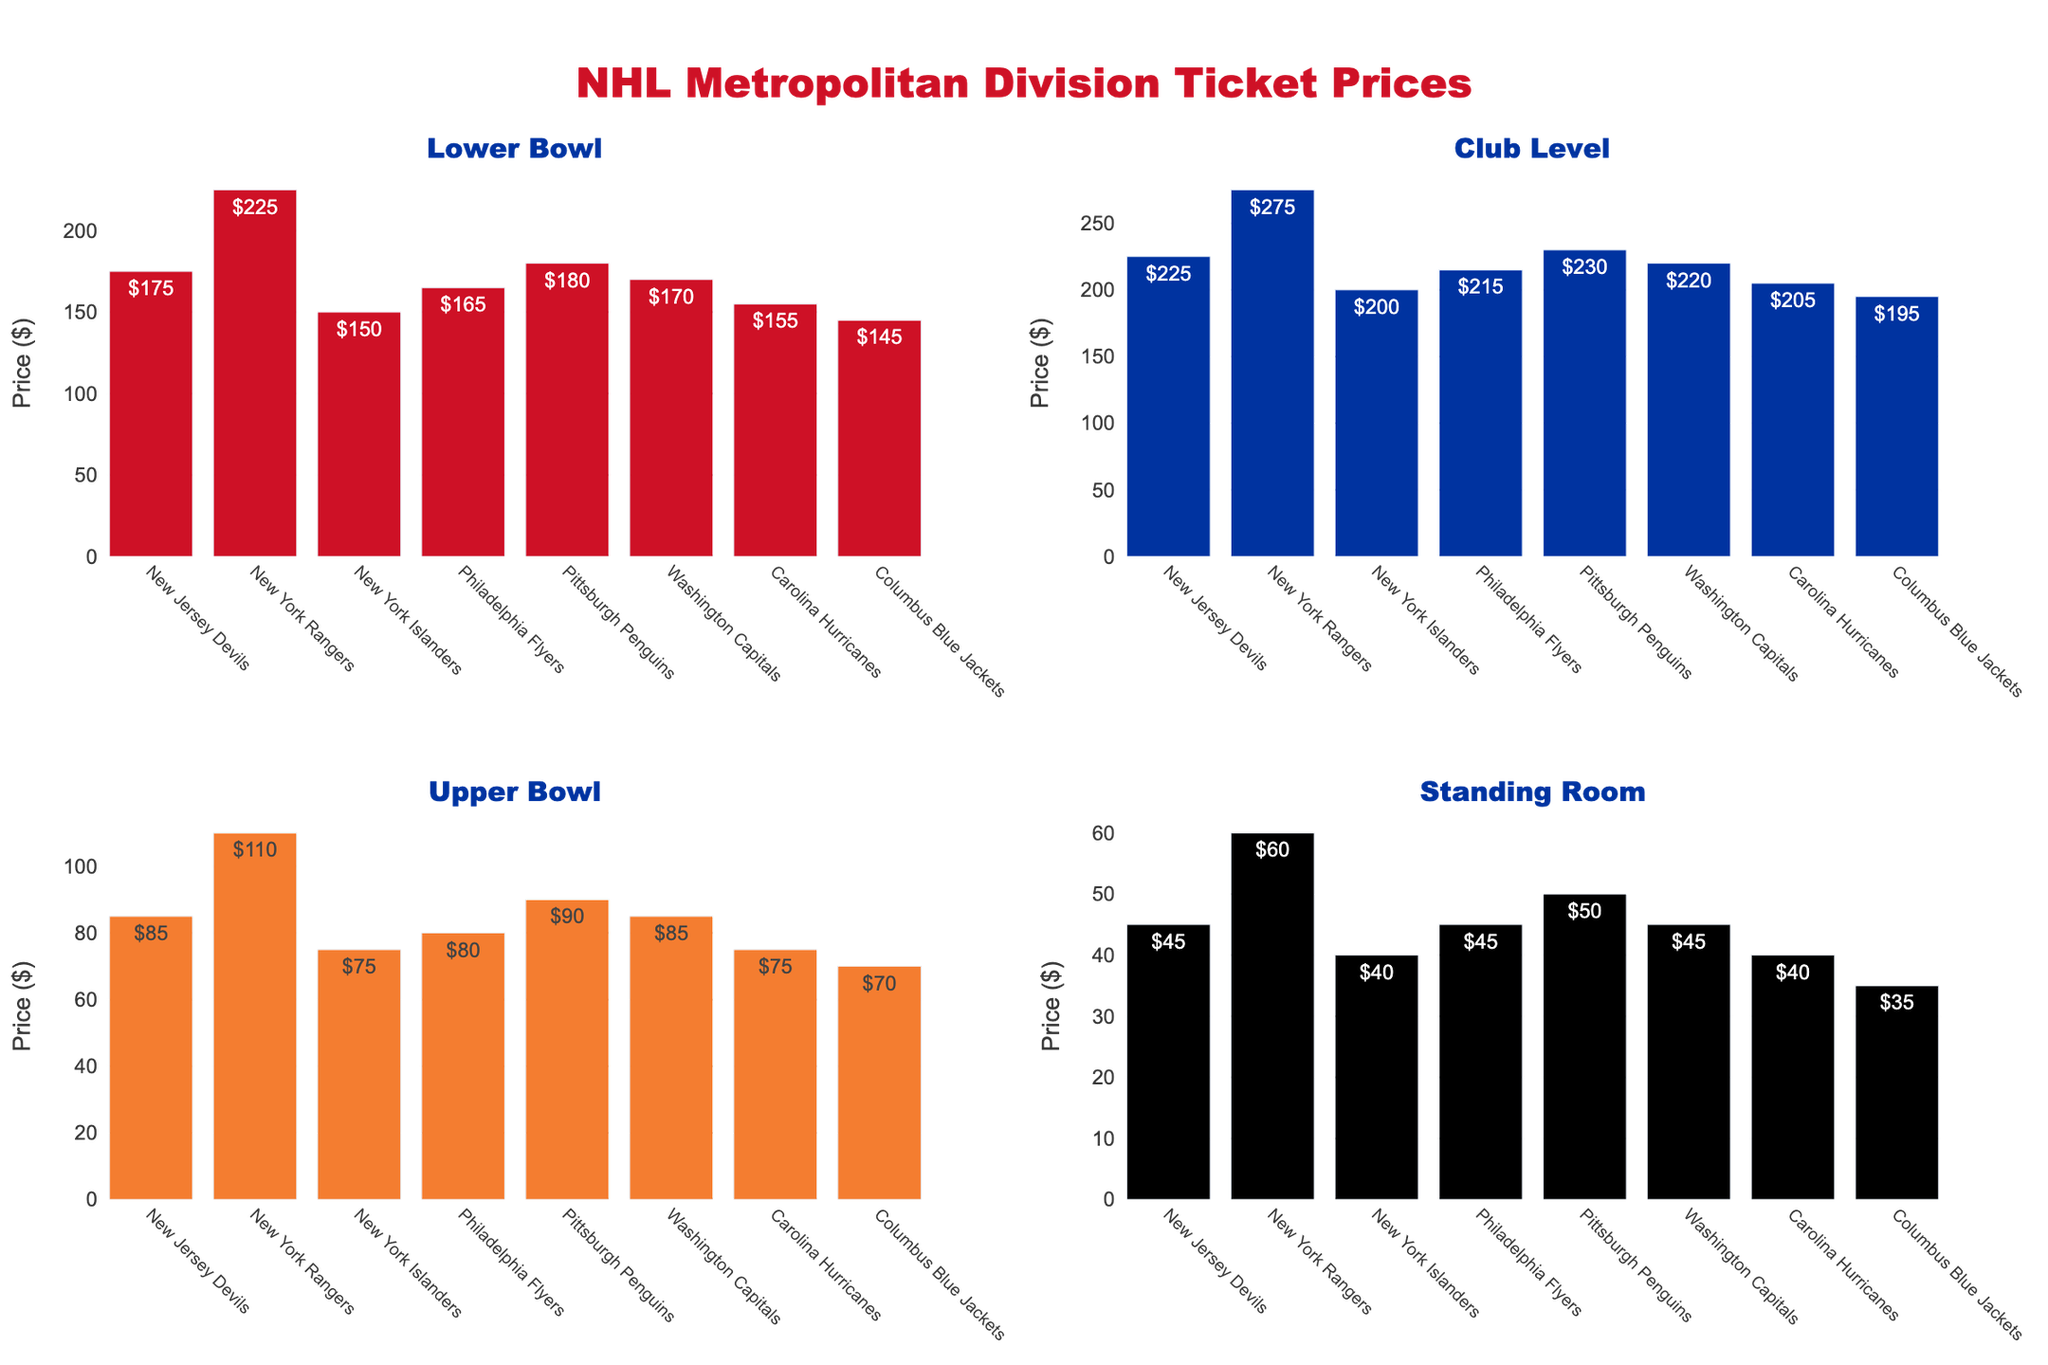Which art medium has the highest carbon footprint? The bar chart in the top-left subplot titled "Carbon Footprint" shows different mediums. The highest bar belongs to Oil Paint.
Answer: Oil Paint Which art medium has the largest value in the water usage scatter plot? The scatter plot in the top-right subplot titled "Water Usage" shows markers at different heights. The highest marker corresponds to Oil Paint.
Answer: Oil Paint Which art medium has the lowest waste production? The bar chart in the bottom-left subplot titled "Waste Production" shows different mediums. The shortest bar represents Digital Art.
Answer: Digital Art What percentage of the recyclability pie chart does Natural Pigments contribute to? The pie chart in the bottom-right subplot titled "Recyclability" assigns a slice to each medium. The label for Natural Pigments shows a value of 90%.
Answer: 90% Compare the carbon footprint for Acrylic Paint and Eco-Friendly Acrylic. Which is higher? In the "Carbon Footprint" bar chart, the bar for Acrylic Paint is higher than the bar for Eco-Friendly Acrylic.
Answer: Acrylic Paint What is the total water usage for Oil Paint and Acrylic Paint combined? From the scatter plot, Oil Paint has a water usage of 3.5L and Acrylic Paint has 2.8L. Summing these gives 3.5 + 2.8 = 6.3L.
Answer: 6.3 Liters How does the waste produced by Sustainable Sculpture Materials compare to that of Watercolor? From the "Waste Production" bar chart, Sustainable Sculpture Materials produce more waste (0.8 kg) than Watercolor (0.5 kg).
Answer: Sustainable Sculpture Materials produce more What is the difference in carbon footprint between Digital Art and Eco-Friendly Acrylic? In the "Carbon Footprint" bar chart, Digital Art has a carbon footprint of 2.5 kg CO2e, and Eco-Friendly Acrylic has 5.1 kg CO2e. The difference is 5.1 - 2.5 = 2.6 kg CO2e.
Answer: 2.6 kg CO2e List all art mediums that have a recyclability percentage of 75% or higher. In the "Recyclability" pie chart, the labels for Eco-Friendly Acrylic (75%), Natural Pigments (90%), Digital Art (95%), Recycled Paper Collage (98%), and Sustainable Sculpture Materials (85%) are all 75% or higher.
Answer: Eco-Friendly Acrylic, Natural Pigments, Digital Art, Recycled Paper Collage, Sustainable Sculpture Materials What are the primary colors used in the plot? The color palette for the bar and pie charts uses a variety of distinctive and vibrant colors. These include shades of red, green, blue, orange, teal, light blue, yellow, and maroon.
Answer: Red, Green, Blue, Orange, Teal, Light Blue, Yellow, Maroon 